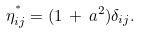<formula> <loc_0><loc_0><loc_500><loc_500>\eta ^ { ^ { * } } _ { i j } = ( 1 \, + \, a ^ { 2 } ) \delta _ { i j } .</formula> 